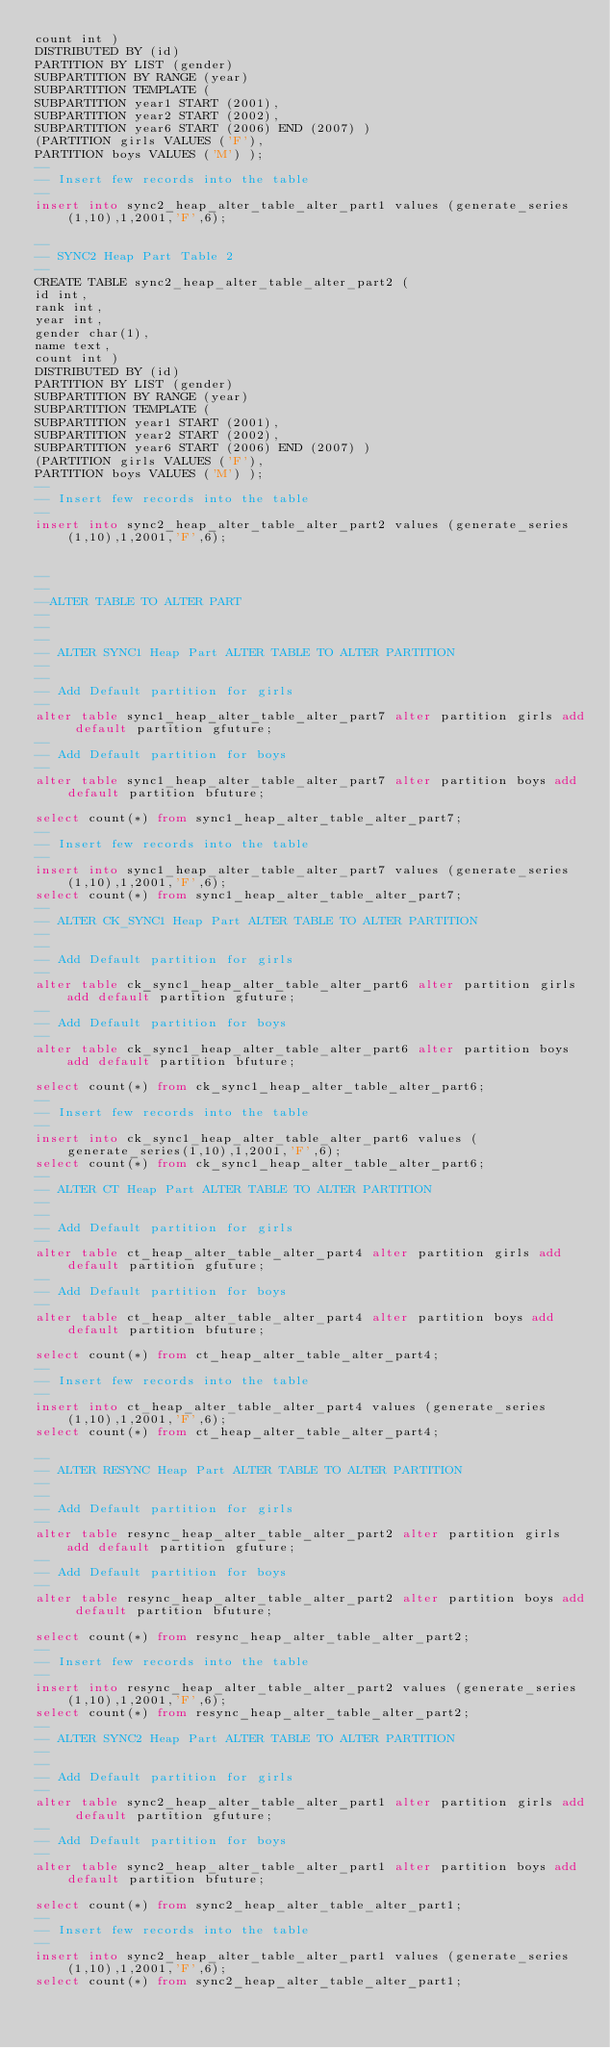Convert code to text. <code><loc_0><loc_0><loc_500><loc_500><_SQL_>count int ) 
DISTRIBUTED BY (id)
PARTITION BY LIST (gender)
SUBPARTITION BY RANGE (year)
SUBPARTITION TEMPLATE (
SUBPARTITION year1 START (2001),
SUBPARTITION year2 START (2002),
SUBPARTITION year6 START (2006) END (2007) )
(PARTITION girls VALUES ('F'),
PARTITION boys VALUES ('M') );
--
-- Insert few records into the table
--
insert into sync2_heap_alter_table_alter_part1 values (generate_series(1,10),1,2001,'F',6);

--
-- SYNC2 Heap Part Table 2
--
CREATE TABLE sync2_heap_alter_table_alter_part2 (
id int,
rank int,
year int,
gender char(1),
name text,
count int ) 
DISTRIBUTED BY (id)
PARTITION BY LIST (gender)
SUBPARTITION BY RANGE (year)
SUBPARTITION TEMPLATE (
SUBPARTITION year1 START (2001),
SUBPARTITION year2 START (2002),
SUBPARTITION year6 START (2006) END (2007) )
(PARTITION girls VALUES ('F'),
PARTITION boys VALUES ('M') );
--
-- Insert few records into the table
--
insert into sync2_heap_alter_table_alter_part2 values (generate_series(1,10),1,2001,'F',6);


--
--
--ALTER TABLE TO ALTER PART
--
--
--
-- ALTER SYNC1 Heap Part ALTER TABLE TO ALTER PARTITION
--
--
-- Add Default partition for girls
--
alter table sync1_heap_alter_table_alter_part7 alter partition girls add default partition gfuture;
--
-- Add Default partition for boys
--
alter table sync1_heap_alter_table_alter_part7 alter partition boys add default partition bfuture;

select count(*) from sync1_heap_alter_table_alter_part7;
--
-- Insert few records into the table
--
insert into sync1_heap_alter_table_alter_part7 values (generate_series(1,10),1,2001,'F',6);
select count(*) from sync1_heap_alter_table_alter_part7;
--
-- ALTER CK_SYNC1 Heap Part ALTER TABLE TO ALTER PARTITION
--
--
-- Add Default partition for girls
--
alter table ck_sync1_heap_alter_table_alter_part6 alter partition girls add default partition gfuture;
--
-- Add Default partition for boys
--
alter table ck_sync1_heap_alter_table_alter_part6 alter partition boys add default partition bfuture;

select count(*) from ck_sync1_heap_alter_table_alter_part6;
--
-- Insert few records into the table
--
insert into ck_sync1_heap_alter_table_alter_part6 values (generate_series(1,10),1,2001,'F',6);
select count(*) from ck_sync1_heap_alter_table_alter_part6;
--
-- ALTER CT Heap Part ALTER TABLE TO ALTER PARTITION
--
--
-- Add Default partition for girls
--
alter table ct_heap_alter_table_alter_part4 alter partition girls add default partition gfuture;
--
-- Add Default partition for boys
--
alter table ct_heap_alter_table_alter_part4 alter partition boys add default partition bfuture;

select count(*) from ct_heap_alter_table_alter_part4;
--
-- Insert few records into the table
--
insert into ct_heap_alter_table_alter_part4 values (generate_series(1,10),1,2001,'F',6);
select count(*) from ct_heap_alter_table_alter_part4;

--
-- ALTER RESYNC Heap Part ALTER TABLE TO ALTER PARTITION
--
--
-- Add Default partition for girls
--
alter table resync_heap_alter_table_alter_part2 alter partition girls add default partition gfuture;
--
-- Add Default partition for boys
--
alter table resync_heap_alter_table_alter_part2 alter partition boys add default partition bfuture;

select count(*) from resync_heap_alter_table_alter_part2;
--
-- Insert few records into the table
--
insert into resync_heap_alter_table_alter_part2 values (generate_series(1,10),1,2001,'F',6);
select count(*) from resync_heap_alter_table_alter_part2;
--
-- ALTER SYNC2 Heap Part ALTER TABLE TO ALTER PARTITION
--
--
-- Add Default partition for girls
--
alter table sync2_heap_alter_table_alter_part1 alter partition girls add default partition gfuture;
--
-- Add Default partition for boys
--
alter table sync2_heap_alter_table_alter_part1 alter partition boys add default partition bfuture;

select count(*) from sync2_heap_alter_table_alter_part1;
--
-- Insert few records into the table
--
insert into sync2_heap_alter_table_alter_part1 values (generate_series(1,10),1,2001,'F',6);
select count(*) from sync2_heap_alter_table_alter_part1;


</code> 